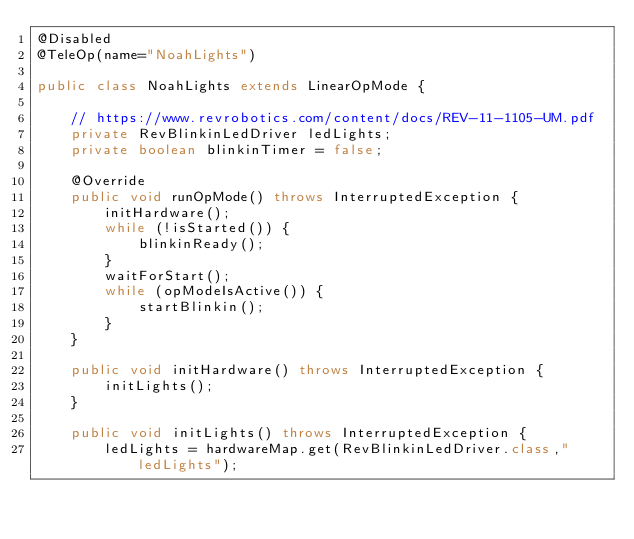<code> <loc_0><loc_0><loc_500><loc_500><_Java_>@Disabled
@TeleOp(name="NoahLights")

public class NoahLights extends LinearOpMode {

    // https://www.revrobotics.com/content/docs/REV-11-1105-UM.pdf
    private RevBlinkinLedDriver ledLights;
    private boolean blinkinTimer = false;

    @Override
    public void runOpMode() throws InterruptedException {
        initHardware();
        while (!isStarted()) {
            blinkinReady();
        }
        waitForStart();
        while (opModeIsActive()) {
            startBlinkin();
        }
    }

    public void initHardware() throws InterruptedException {
        initLights();
    }

    public void initLights() throws InterruptedException {
        ledLights = hardwareMap.get(RevBlinkinLedDriver.class,"ledLights");</code> 